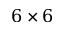<formula> <loc_0><loc_0><loc_500><loc_500>6 \times 6</formula> 